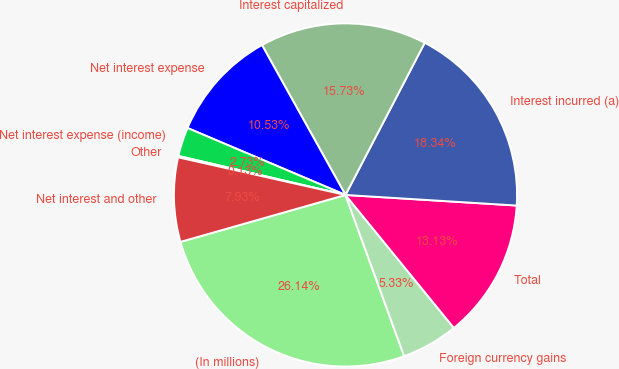Convert chart to OTSL. <chart><loc_0><loc_0><loc_500><loc_500><pie_chart><fcel>(In millions)<fcel>Foreign currency gains<fcel>Total<fcel>Interest incurred (a)<fcel>Interest capitalized<fcel>Net interest expense<fcel>Net interest expense (income)<fcel>Other<fcel>Net interest and other<nl><fcel>26.14%<fcel>5.33%<fcel>13.13%<fcel>18.34%<fcel>15.73%<fcel>10.53%<fcel>2.73%<fcel>0.13%<fcel>7.93%<nl></chart> 